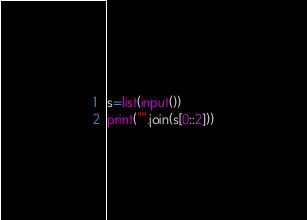Convert code to text. <code><loc_0><loc_0><loc_500><loc_500><_Python_>s=list(input())
print("".join(s[0::2]))</code> 